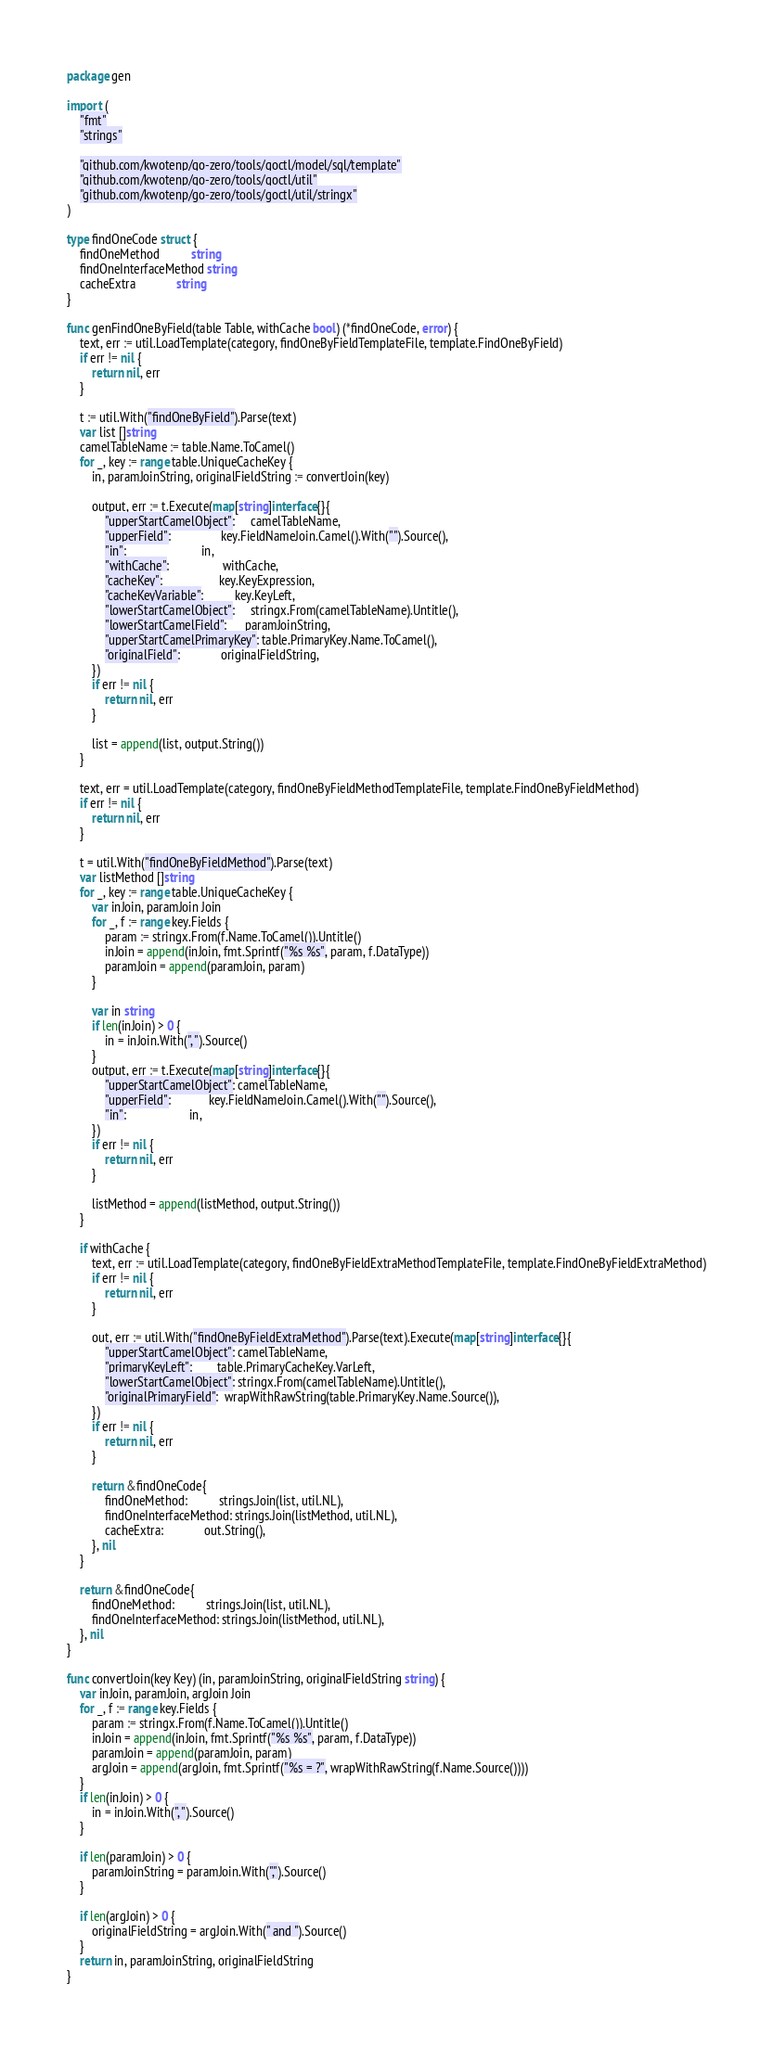<code> <loc_0><loc_0><loc_500><loc_500><_Go_>package gen

import (
	"fmt"
	"strings"

	"github.com/kwotenp/go-zero/tools/goctl/model/sql/template"
	"github.com/kwotenp/go-zero/tools/goctl/util"
	"github.com/kwotenp/go-zero/tools/goctl/util/stringx"
)

type findOneCode struct {
	findOneMethod          string
	findOneInterfaceMethod string
	cacheExtra             string
}

func genFindOneByField(table Table, withCache bool) (*findOneCode, error) {
	text, err := util.LoadTemplate(category, findOneByFieldTemplateFile, template.FindOneByField)
	if err != nil {
		return nil, err
	}

	t := util.With("findOneByField").Parse(text)
	var list []string
	camelTableName := table.Name.ToCamel()
	for _, key := range table.UniqueCacheKey {
		in, paramJoinString, originalFieldString := convertJoin(key)

		output, err := t.Execute(map[string]interface{}{
			"upperStartCamelObject":     camelTableName,
			"upperField":                key.FieldNameJoin.Camel().With("").Source(),
			"in":                        in,
			"withCache":                 withCache,
			"cacheKey":                  key.KeyExpression,
			"cacheKeyVariable":          key.KeyLeft,
			"lowerStartCamelObject":     stringx.From(camelTableName).Untitle(),
			"lowerStartCamelField":      paramJoinString,
			"upperStartCamelPrimaryKey": table.PrimaryKey.Name.ToCamel(),
			"originalField":             originalFieldString,
		})
		if err != nil {
			return nil, err
		}

		list = append(list, output.String())
	}

	text, err = util.LoadTemplate(category, findOneByFieldMethodTemplateFile, template.FindOneByFieldMethod)
	if err != nil {
		return nil, err
	}

	t = util.With("findOneByFieldMethod").Parse(text)
	var listMethod []string
	for _, key := range table.UniqueCacheKey {
		var inJoin, paramJoin Join
		for _, f := range key.Fields {
			param := stringx.From(f.Name.ToCamel()).Untitle()
			inJoin = append(inJoin, fmt.Sprintf("%s %s", param, f.DataType))
			paramJoin = append(paramJoin, param)
		}

		var in string
		if len(inJoin) > 0 {
			in = inJoin.With(", ").Source()
		}
		output, err := t.Execute(map[string]interface{}{
			"upperStartCamelObject": camelTableName,
			"upperField":            key.FieldNameJoin.Camel().With("").Source(),
			"in":                    in,
		})
		if err != nil {
			return nil, err
		}

		listMethod = append(listMethod, output.String())
	}

	if withCache {
		text, err := util.LoadTemplate(category, findOneByFieldExtraMethodTemplateFile, template.FindOneByFieldExtraMethod)
		if err != nil {
			return nil, err
		}

		out, err := util.With("findOneByFieldExtraMethod").Parse(text).Execute(map[string]interface{}{
			"upperStartCamelObject": camelTableName,
			"primaryKeyLeft":        table.PrimaryCacheKey.VarLeft,
			"lowerStartCamelObject": stringx.From(camelTableName).Untitle(),
			"originalPrimaryField":  wrapWithRawString(table.PrimaryKey.Name.Source()),
		})
		if err != nil {
			return nil, err
		}

		return &findOneCode{
			findOneMethod:          strings.Join(list, util.NL),
			findOneInterfaceMethod: strings.Join(listMethod, util.NL),
			cacheExtra:             out.String(),
		}, nil
	}

	return &findOneCode{
		findOneMethod:          strings.Join(list, util.NL),
		findOneInterfaceMethod: strings.Join(listMethod, util.NL),
	}, nil
}

func convertJoin(key Key) (in, paramJoinString, originalFieldString string) {
	var inJoin, paramJoin, argJoin Join
	for _, f := range key.Fields {
		param := stringx.From(f.Name.ToCamel()).Untitle()
		inJoin = append(inJoin, fmt.Sprintf("%s %s", param, f.DataType))
		paramJoin = append(paramJoin, param)
		argJoin = append(argJoin, fmt.Sprintf("%s = ?", wrapWithRawString(f.Name.Source())))
	}
	if len(inJoin) > 0 {
		in = inJoin.With(", ").Source()
	}

	if len(paramJoin) > 0 {
		paramJoinString = paramJoin.With(",").Source()
	}

	if len(argJoin) > 0 {
		originalFieldString = argJoin.With(" and ").Source()
	}
	return in, paramJoinString, originalFieldString
}
</code> 